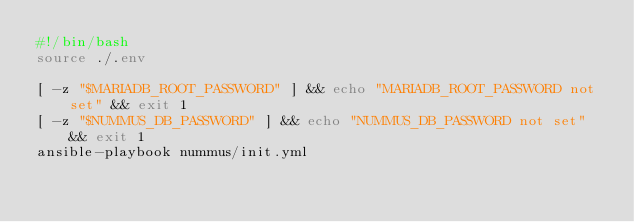Convert code to text. <code><loc_0><loc_0><loc_500><loc_500><_Bash_>#!/bin/bash
source ./.env

[ -z "$MARIADB_ROOT_PASSWORD" ] && echo "MARIADB_ROOT_PASSWORD not set" && exit 1
[ -z "$NUMMUS_DB_PASSWORD" ] && echo "NUMMUS_DB_PASSWORD not set" && exit 1
ansible-playbook nummus/init.yml</code> 